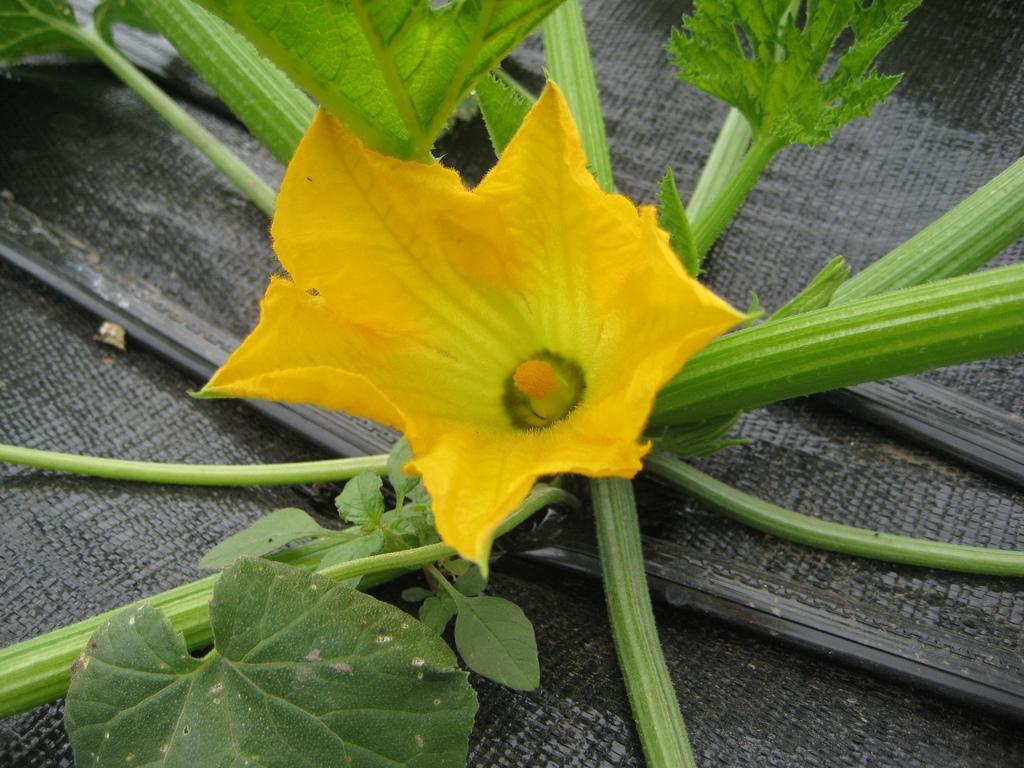Please provide a concise description of this image. This image consists of a flower which is in the center and there are leaves. 